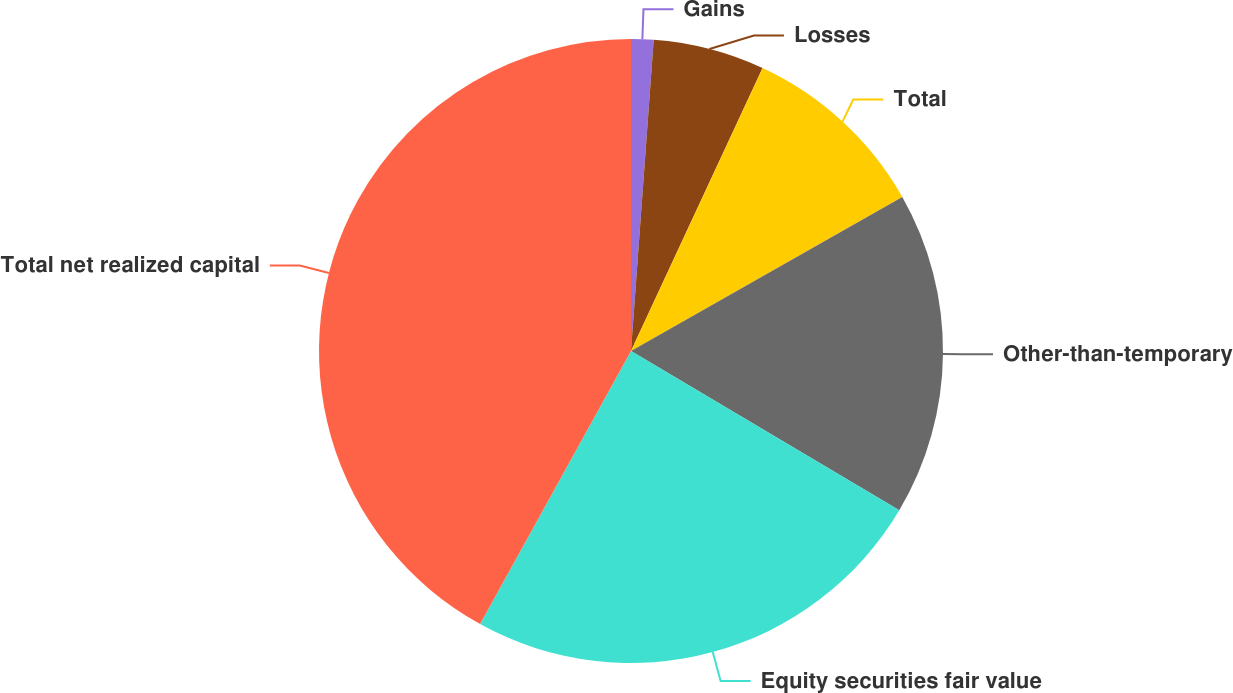Convert chart. <chart><loc_0><loc_0><loc_500><loc_500><pie_chart><fcel>Gains<fcel>Losses<fcel>Total<fcel>Other-than-temporary<fcel>Equity securities fair value<fcel>Total net realized capital<nl><fcel>1.16%<fcel>5.77%<fcel>9.85%<fcel>16.75%<fcel>24.51%<fcel>41.97%<nl></chart> 